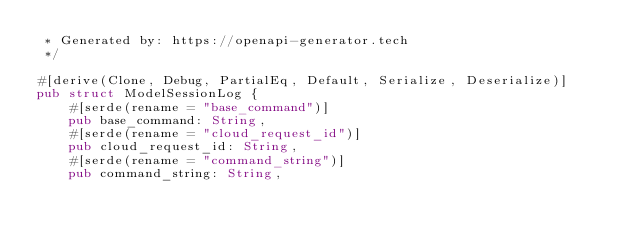Convert code to text. <code><loc_0><loc_0><loc_500><loc_500><_Rust_> * Generated by: https://openapi-generator.tech
 */

#[derive(Clone, Debug, PartialEq, Default, Serialize, Deserialize)]
pub struct ModelSessionLog {
    #[serde(rename = "base_command")]
    pub base_command: String,
    #[serde(rename = "cloud_request_id")]
    pub cloud_request_id: String,
    #[serde(rename = "command_string")]
    pub command_string: String,</code> 